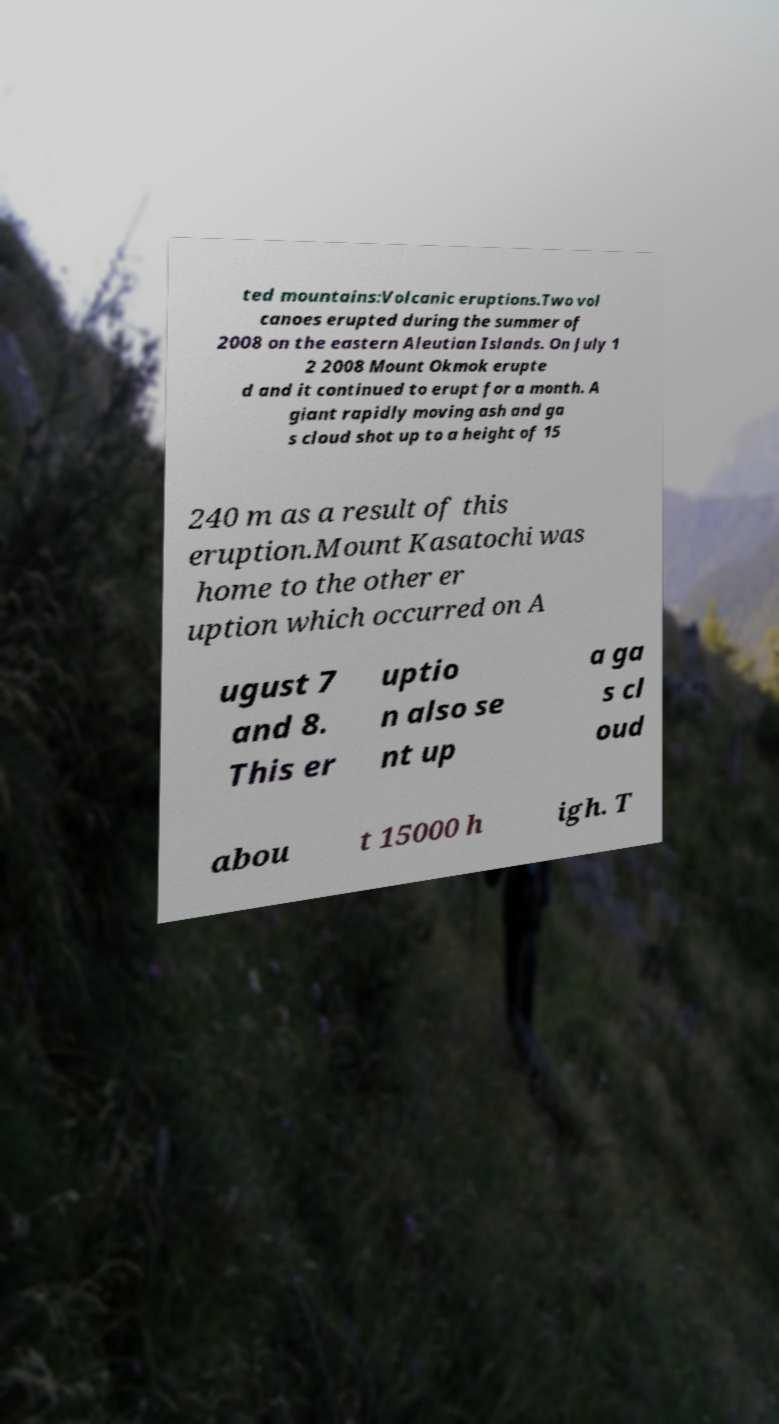Please read and relay the text visible in this image. What does it say? ted mountains:Volcanic eruptions.Two vol canoes erupted during the summer of 2008 on the eastern Aleutian Islands. On July 1 2 2008 Mount Okmok erupte d and it continued to erupt for a month. A giant rapidly moving ash and ga s cloud shot up to a height of 15 240 m as a result of this eruption.Mount Kasatochi was home to the other er uption which occurred on A ugust 7 and 8. This er uptio n also se nt up a ga s cl oud abou t 15000 h igh. T 